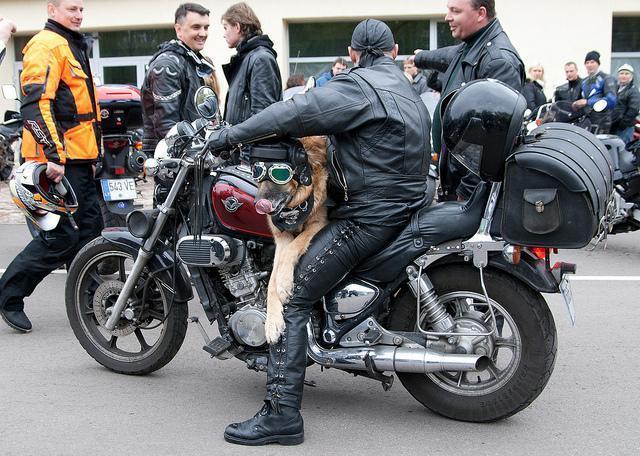How many people can the motorcycle fit on it?
Give a very brief answer. 2. How many people are wearing orange shirts?
Give a very brief answer. 1. How many people are there?
Give a very brief answer. 6. How many dogs are in the photo?
Give a very brief answer. 1. How many bears are in the chair?
Give a very brief answer. 0. 